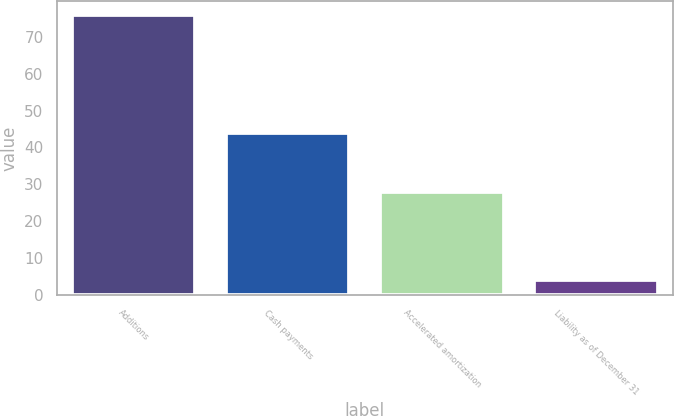Convert chart to OTSL. <chart><loc_0><loc_0><loc_500><loc_500><bar_chart><fcel>Additions<fcel>Cash payments<fcel>Accelerated amortization<fcel>Liability as of December 31<nl><fcel>76<fcel>44<fcel>28<fcel>4<nl></chart> 